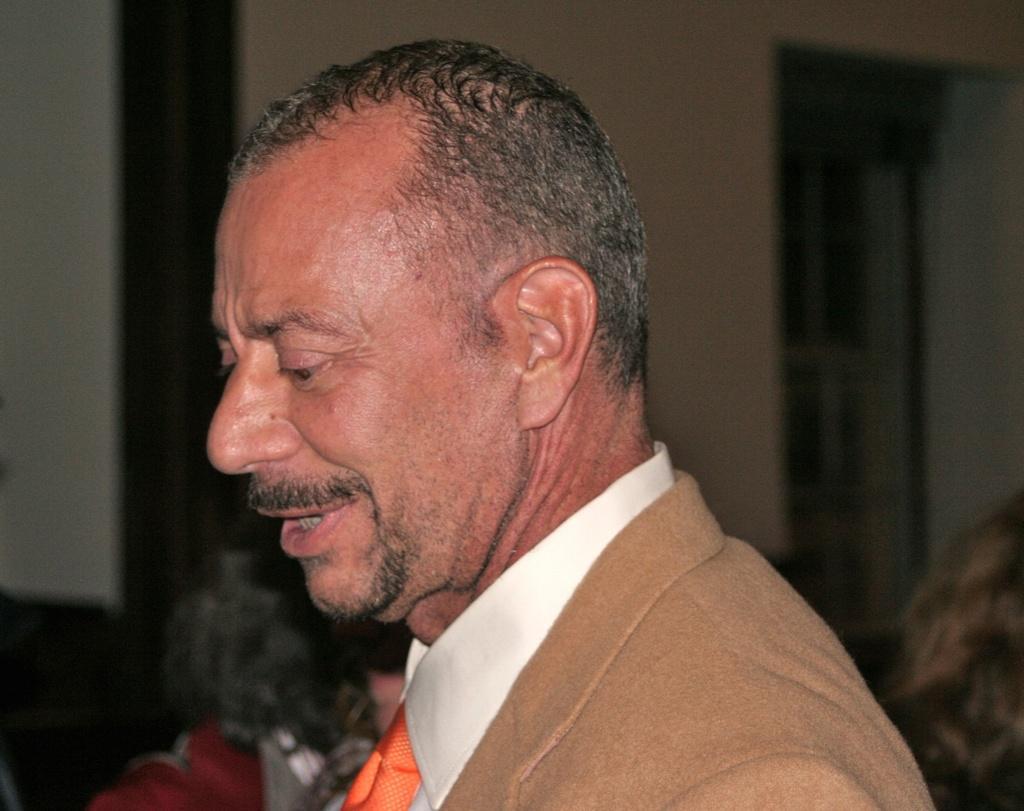How would you summarize this image in a sentence or two? In this image, I can see a man. There is a blurred background. 